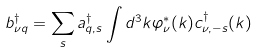<formula> <loc_0><loc_0><loc_500><loc_500>b ^ { \dag } _ { \nu { q } } = \sum _ { s } a ^ { \dag } _ { { q } , s } \int d ^ { 3 } k \varphi ^ { * } _ { \nu } ( { k } ) c ^ { \dag } _ { \nu , - s } ( { k } )</formula> 